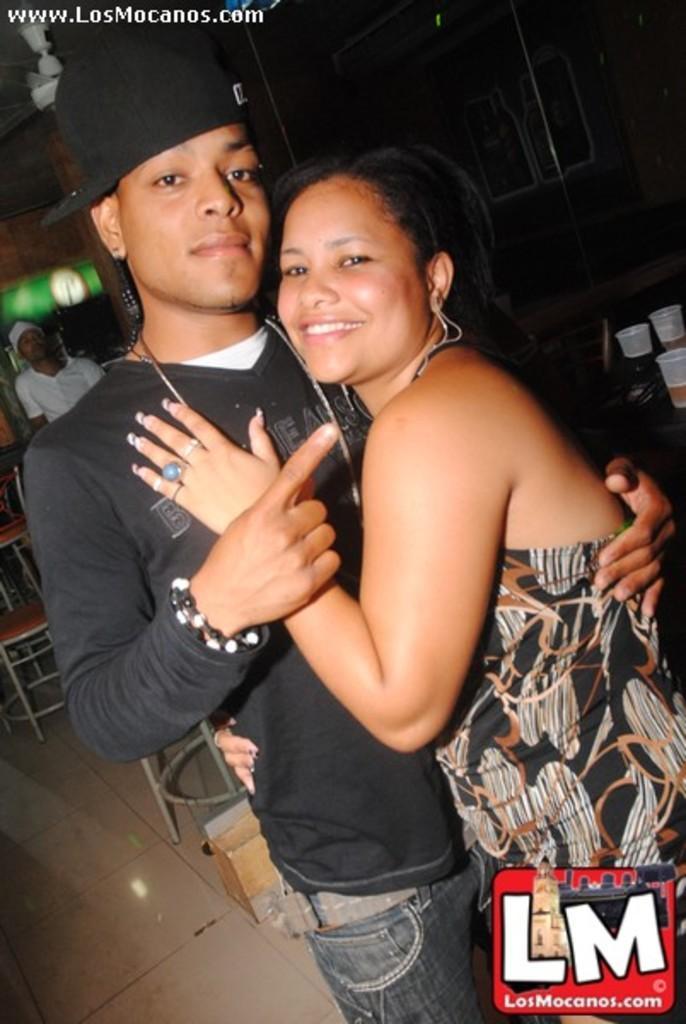Please provide a concise description of this image. This is the man and woman standing and smiling. This looks like a chair. These are the glasses placed on the table. In the background, I can see a person standing. This is the ceiling fan, which is attached to the roof. These are the watermarks on the image. 